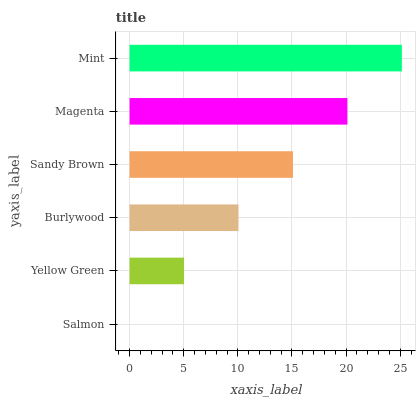Is Salmon the minimum?
Answer yes or no. Yes. Is Mint the maximum?
Answer yes or no. Yes. Is Yellow Green the minimum?
Answer yes or no. No. Is Yellow Green the maximum?
Answer yes or no. No. Is Yellow Green greater than Salmon?
Answer yes or no. Yes. Is Salmon less than Yellow Green?
Answer yes or no. Yes. Is Salmon greater than Yellow Green?
Answer yes or no. No. Is Yellow Green less than Salmon?
Answer yes or no. No. Is Sandy Brown the high median?
Answer yes or no. Yes. Is Burlywood the low median?
Answer yes or no. Yes. Is Mint the high median?
Answer yes or no. No. Is Mint the low median?
Answer yes or no. No. 